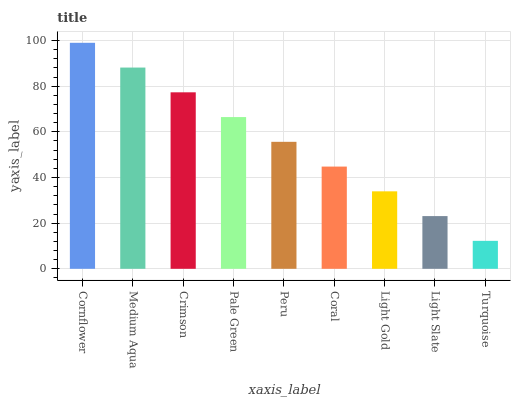Is Turquoise the minimum?
Answer yes or no. Yes. Is Cornflower the maximum?
Answer yes or no. Yes. Is Medium Aqua the minimum?
Answer yes or no. No. Is Medium Aqua the maximum?
Answer yes or no. No. Is Cornflower greater than Medium Aqua?
Answer yes or no. Yes. Is Medium Aqua less than Cornflower?
Answer yes or no. Yes. Is Medium Aqua greater than Cornflower?
Answer yes or no. No. Is Cornflower less than Medium Aqua?
Answer yes or no. No. Is Peru the high median?
Answer yes or no. Yes. Is Peru the low median?
Answer yes or no. Yes. Is Turquoise the high median?
Answer yes or no. No. Is Crimson the low median?
Answer yes or no. No. 